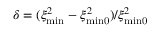<formula> <loc_0><loc_0><loc_500><loc_500>\delta = ( \xi _ { \min } ^ { 2 } - \xi _ { \min 0 } ^ { 2 } ) / \xi _ { \min 0 } ^ { 2 }</formula> 